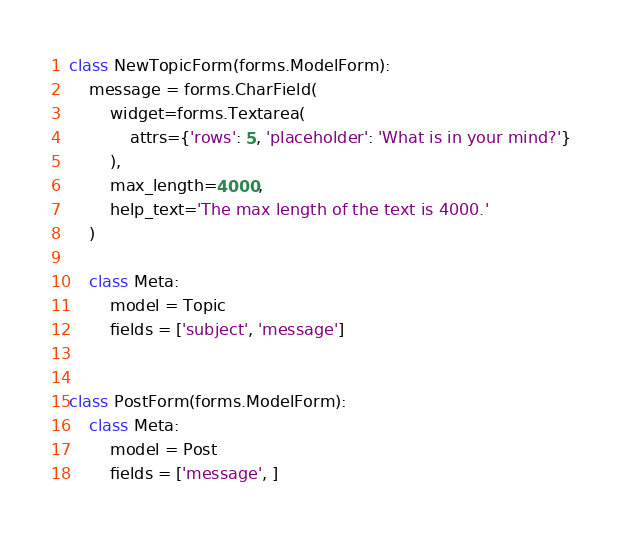Convert code to text. <code><loc_0><loc_0><loc_500><loc_500><_Python_>

class NewTopicForm(forms.ModelForm):
    message = forms.CharField(
        widget=forms.Textarea(
            attrs={'rows': 5, 'placeholder': 'What is in your mind?'}
        ),
        max_length=4000,
        help_text='The max length of the text is 4000.'
    )

    class Meta:
        model = Topic
        fields = ['subject', 'message']


class PostForm(forms.ModelForm):
    class Meta:
        model = Post
        fields = ['message', ]
</code> 